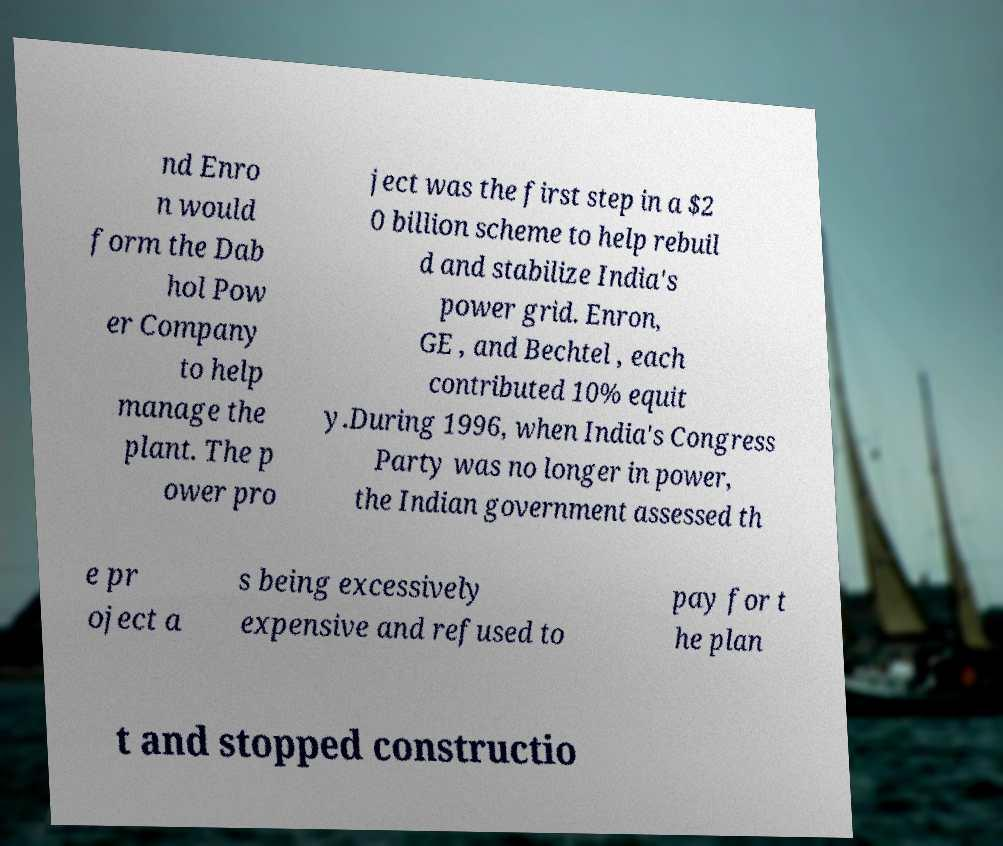Please read and relay the text visible in this image. What does it say? nd Enro n would form the Dab hol Pow er Company to help manage the plant. The p ower pro ject was the first step in a $2 0 billion scheme to help rebuil d and stabilize India's power grid. Enron, GE , and Bechtel , each contributed 10% equit y.During 1996, when India's Congress Party was no longer in power, the Indian government assessed th e pr oject a s being excessively expensive and refused to pay for t he plan t and stopped constructio 